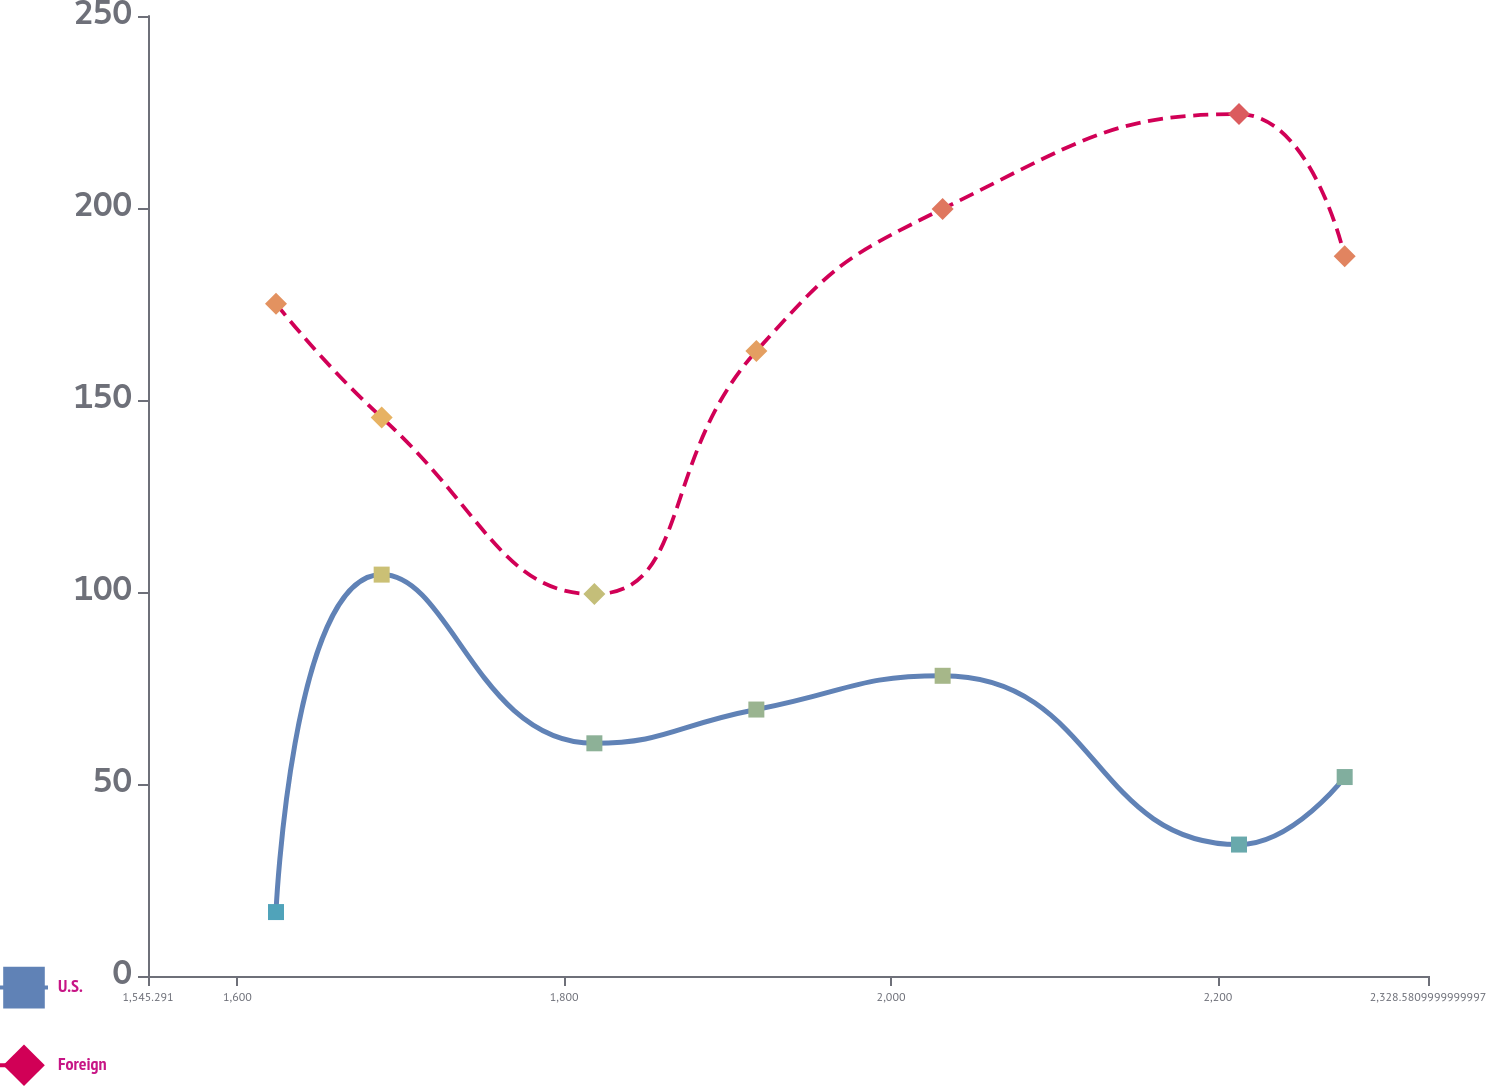Convert chart. <chart><loc_0><loc_0><loc_500><loc_500><line_chart><ecel><fcel>U.S.<fcel>Foreign<nl><fcel>1623.62<fcel>16.65<fcel>175.09<nl><fcel>1688.28<fcel>104.53<fcel>145.45<nl><fcel>1818.45<fcel>60.6<fcel>99.46<nl><fcel>1917.57<fcel>69.39<fcel>162.75<nl><fcel>2031.57<fcel>78.18<fcel>199.77<nl><fcel>2212.93<fcel>34.23<fcel>224.45<nl><fcel>2277.59<fcel>51.81<fcel>187.43<nl><fcel>2342.25<fcel>25.44<fcel>212.11<nl><fcel>2406.91<fcel>43.02<fcel>236.79<nl></chart> 